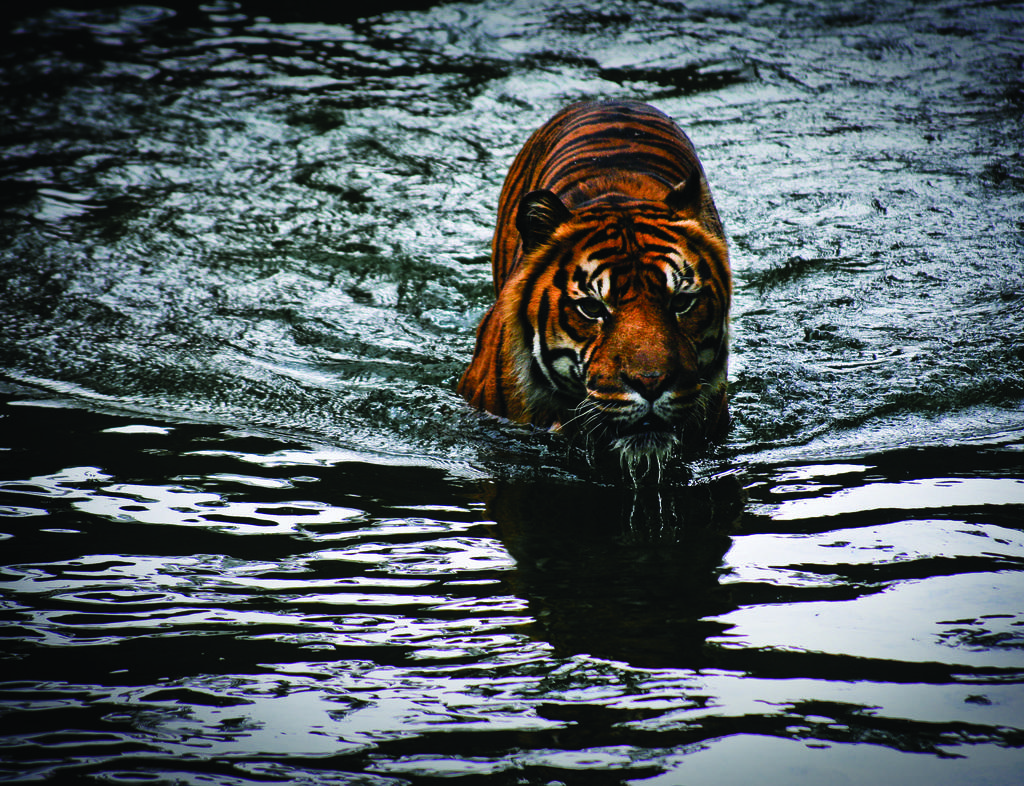What animal is in the image? There is a tiger in the image. Where is the tiger located in the image? The tiger is in the water. What type of trade is happening between the tiger and the tree in the image? There is no trade happening in the image, as there is no tree present. 